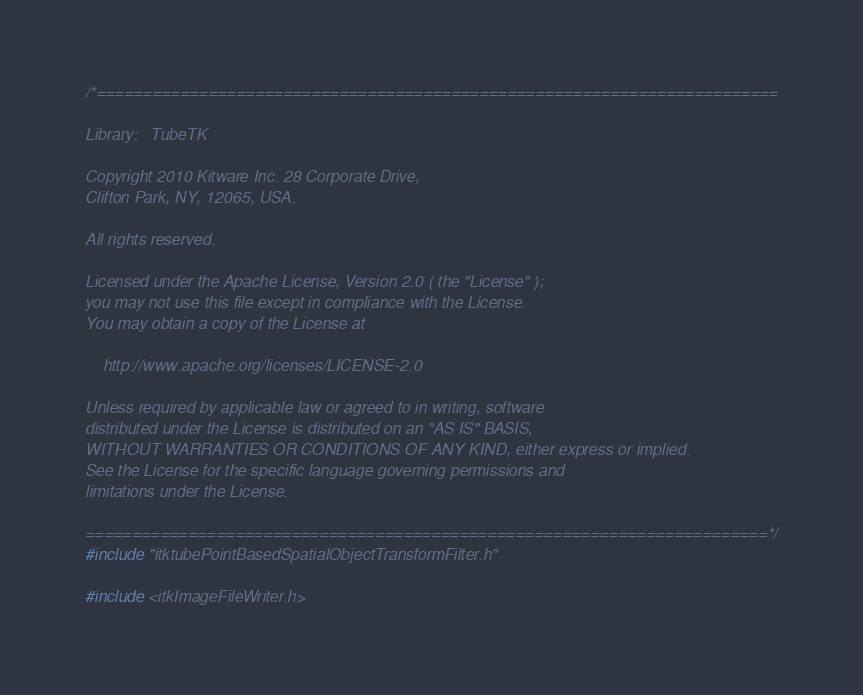<code> <loc_0><loc_0><loc_500><loc_500><_C++_>/*=========================================================================

Library:   TubeTK

Copyright 2010 Kitware Inc. 28 Corporate Drive,
Clifton Park, NY, 12065, USA.

All rights reserved.

Licensed under the Apache License, Version 2.0 ( the "License" );
you may not use this file except in compliance with the License.
You may obtain a copy of the License at

    http://www.apache.org/licenses/LICENSE-2.0

Unless required by applicable law or agreed to in writing, software
distributed under the License is distributed on an "AS IS" BASIS,
WITHOUT WARRANTIES OR CONDITIONS OF ANY KIND, either express or implied.
See the License for the specific language governing permissions and
limitations under the License.

=========================================================================*/
#include "itktubePointBasedSpatialObjectTransformFilter.h"

#include <itkImageFileWriter.h></code> 